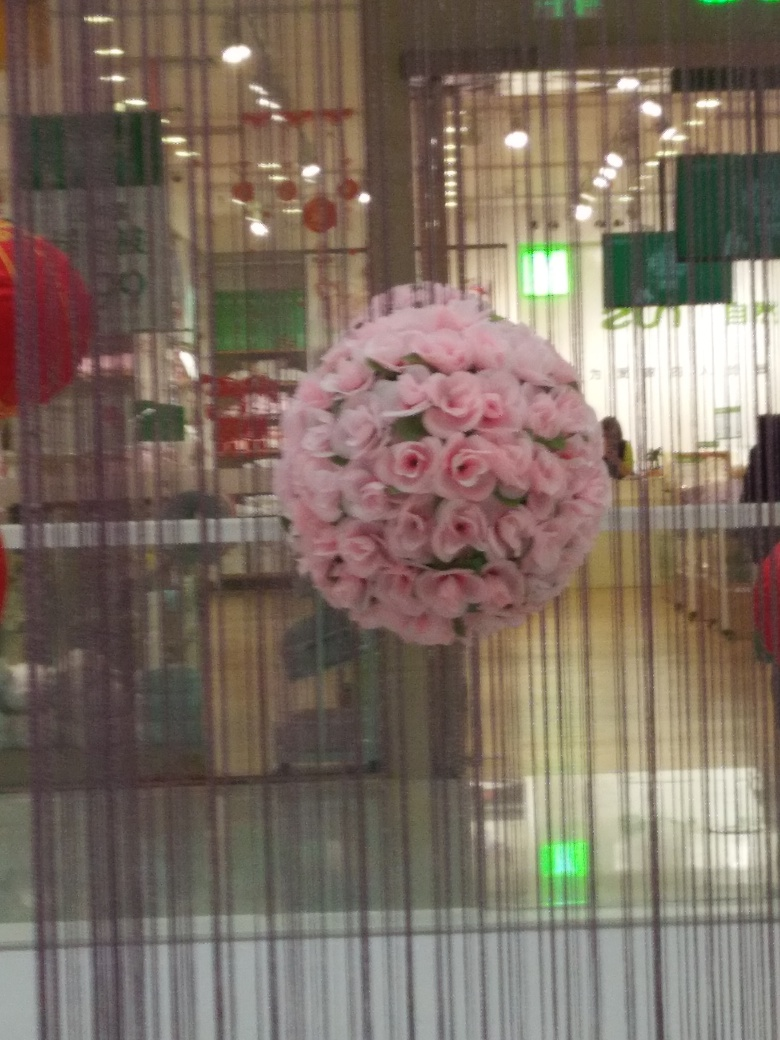What's the significance of the spherical floral arrangement in this photo? The spherical arrangement of pink roses is often associated with celebrations or decorative purposes. It could be part of an event's décor - perhaps a wedding, formal gathering, or part of the festive decorations, perhaps for a holiday like Chinese New Year, indicated by the red lanterns in the background. 